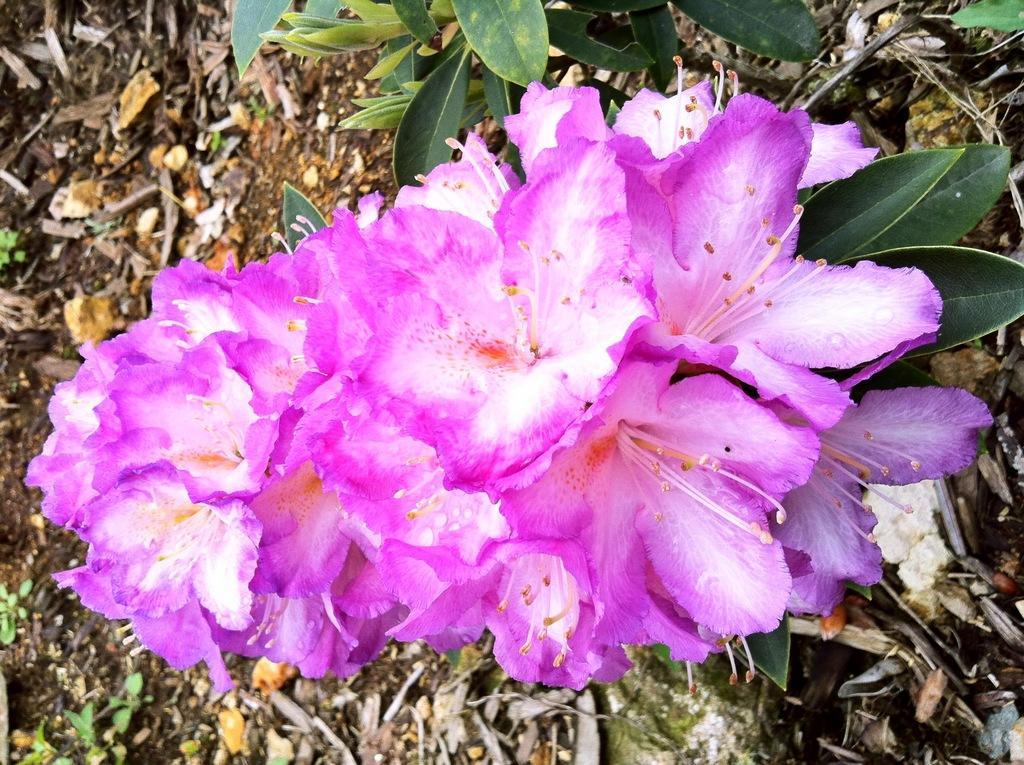How would you summarize this image in a sentence or two? In this image, we can see some flower and there are some green color leaves, we can see some dried leaves on the ground. 